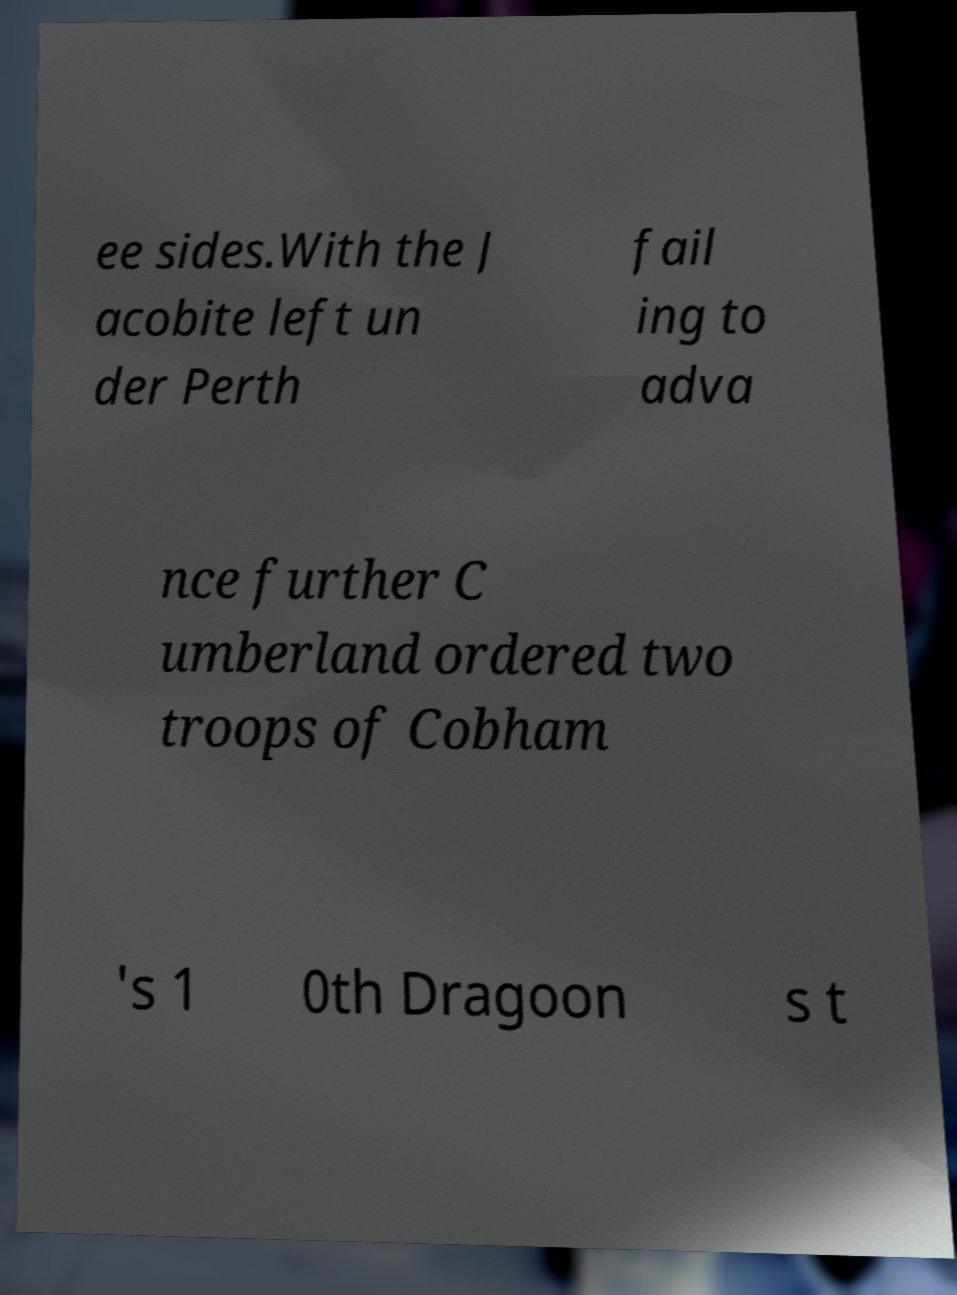For documentation purposes, I need the text within this image transcribed. Could you provide that? ee sides.With the J acobite left un der Perth fail ing to adva nce further C umberland ordered two troops of Cobham 's 1 0th Dragoon s t 